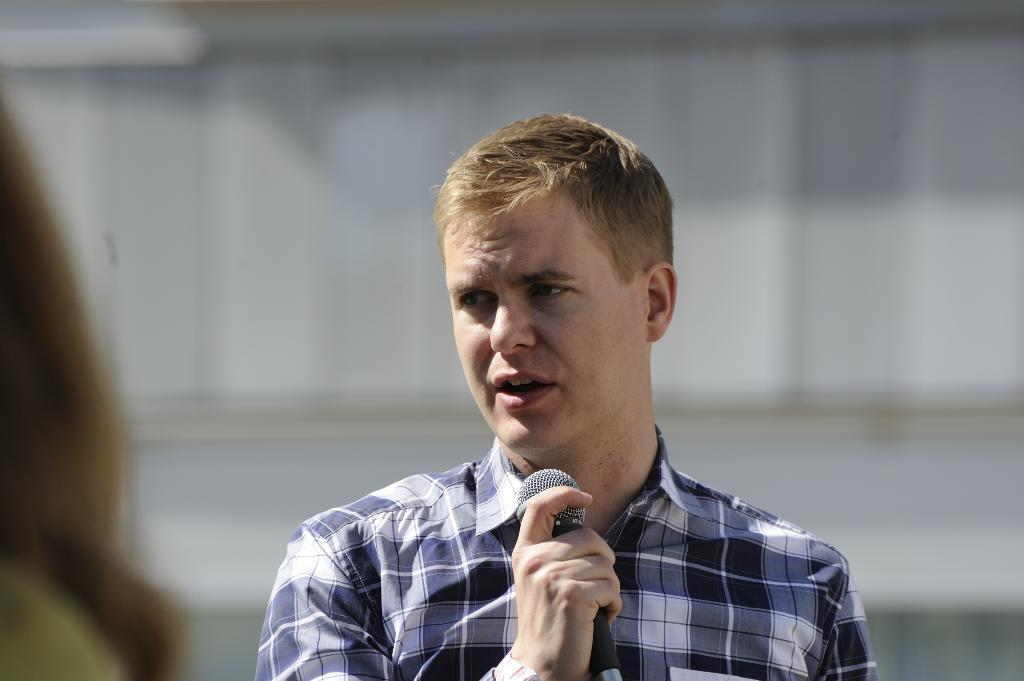What is the main subject of the image? There is a man in the image. What is the man doing in the image? The man is standing in the image. What is the man wearing in the image? The man is wearing a blue shirt in the image. What object is the man holding in the image? The man is holding a microphone in his hand in the image. Are there any other people in the image besides the man? Yes, there is at least one other person in the image. What type of cloth is draped over the sisters in the image? There are no sisters or cloth present in the image. What sound can be heard during the thunderstorm in the image? There is no thunderstorm present in the image. 